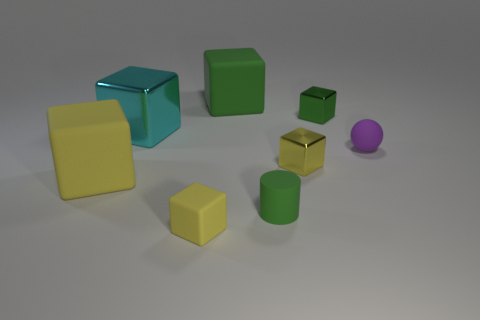How many things are purple objects to the right of the cyan metal object or big rubber blocks on the right side of the big yellow object?
Offer a terse response. 2. There is a purple rubber object; are there any tiny yellow blocks behind it?
Provide a succinct answer. No. What number of things are tiny shiny objects that are in front of the small green shiny block or purple objects?
Provide a succinct answer. 2. What number of gray objects are either small metal objects or spheres?
Ensure brevity in your answer.  0. How many other objects are the same color as the big metal object?
Keep it short and to the point. 0. Is the number of shiny objects left of the tiny rubber block less than the number of large rubber objects?
Your response must be concise. Yes. What color is the small matte thing behind the tiny yellow block that is behind the tiny green thing in front of the large cyan shiny thing?
Offer a terse response. Purple. What size is the yellow metallic thing that is the same shape as the cyan thing?
Ensure brevity in your answer.  Small. Is the number of green rubber things to the right of the small green rubber cylinder less than the number of small matte things that are on the left side of the purple object?
Ensure brevity in your answer.  Yes. What shape is the metallic object that is on the right side of the green cylinder and behind the purple rubber ball?
Make the answer very short. Cube. 